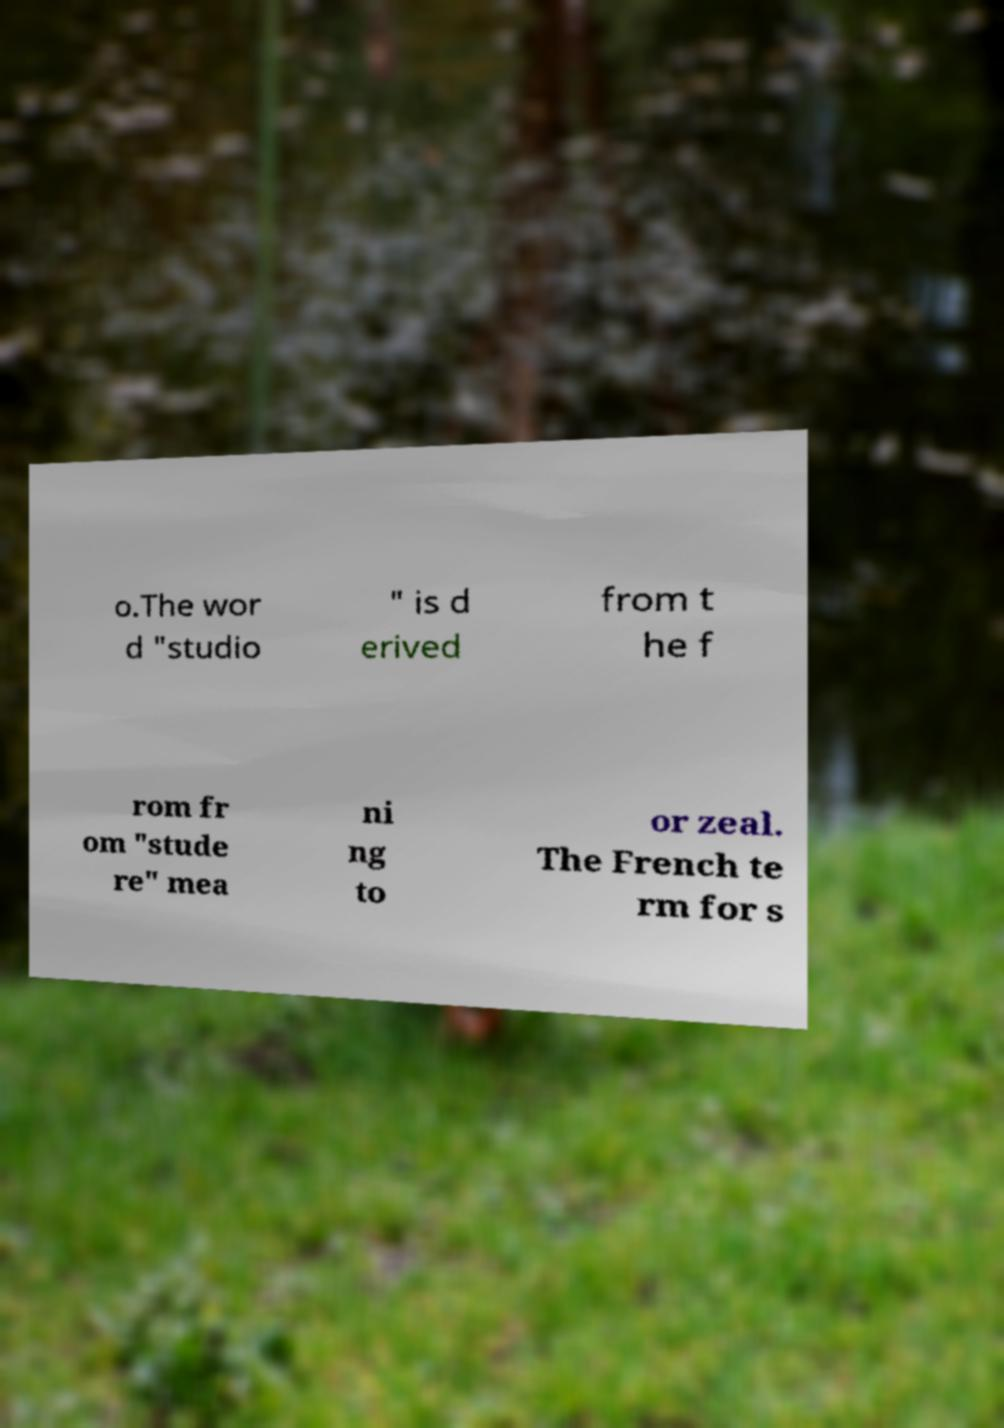Could you assist in decoding the text presented in this image and type it out clearly? o.The wor d "studio " is d erived from t he f rom fr om "stude re" mea ni ng to or zeal. The French te rm for s 